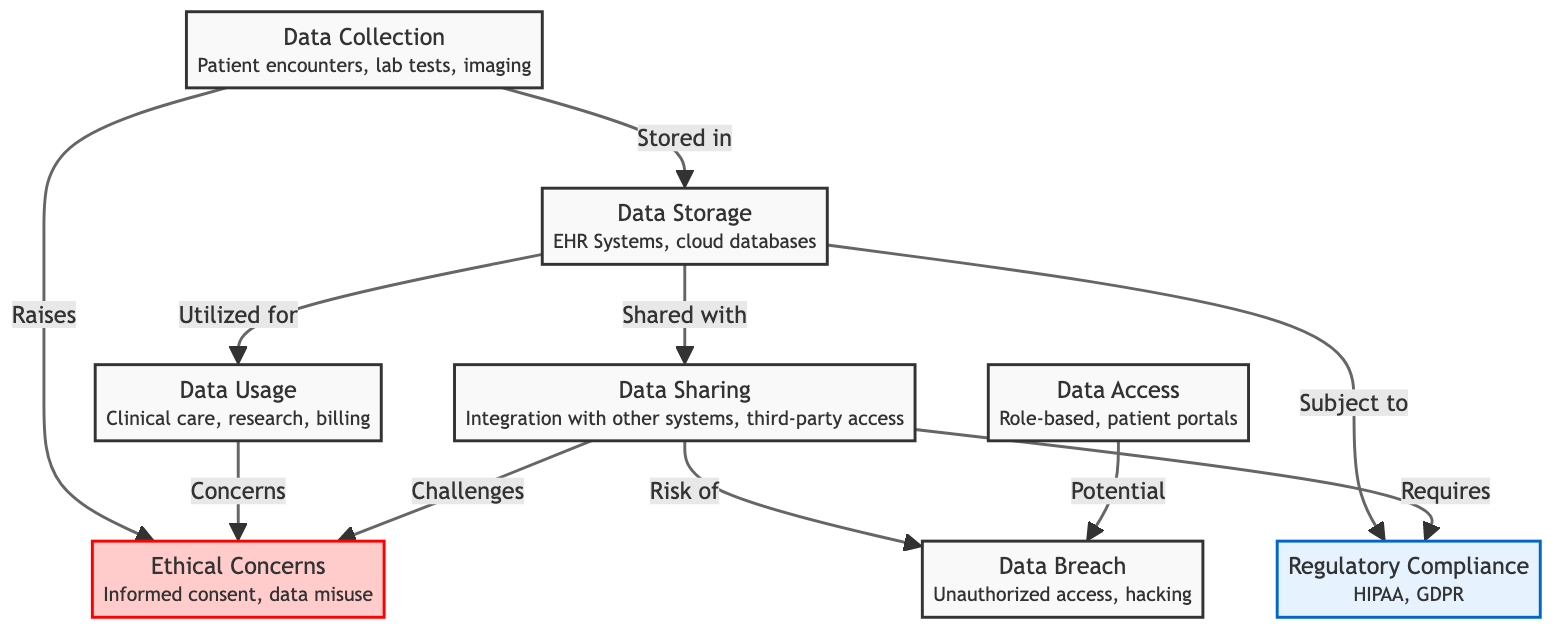What is the first step in the lifecycle of patient data? The diagram indicates that the lifecycle starts with "Data Collection" which involves patient encounters, lab tests, and imaging.
Answer: Data Collection How many main stages are there in the patient data lifecycle? By counting the labeled nodes in the diagram, we see there are six main stages described: Data Collection, Data Storage, Data Usage, Data Sharing, Data Access, and Data Breach.
Answer: Six Which node raises ethical concerns? The diagram shows that both "Data Collection" and "Data Usage" nodes lead to "Ethical Concerns," meaning they are responsible for raising issues regarding informed consent and data misuse.
Answer: Data Collection, Data Usage What type of compliance is required for data sharing? The diagram highlights that "Data Sharing" is an aspect that "Requires" regulatory compliance, specifically illustrating a connection with the "Regulatory Compliance" node, which mentions HIPAA and GDPR.
Answer: Regulatory Compliance What is a potential risk associated with data access? The arrows in the diagram indicate that "Data Access" has a potential risk leading to "Data Breach," demonstrating that unauthorized access and hacking are concerns in this context.
Answer: Data Breach What are two main regulatory compliance standards noted in the diagram? The "Regulatory Compliance" node specifically lists HIPAA and GDPR as the key standards relevant to the handling of patient data according to the diagram.
Answer: HIPAA, GDPR Which nodes flow into the "Ethical Concerns" node? The diagram illustrates that "Data Collection," "Data Usage," and "Data Sharing" all lead into the "Ethical Concerns" node, indicating multiple processes can raise ethical issues.
Answer: Data Collection, Data Usage, Data Sharing Which step involves integration with other systems? The "Data Sharing" node explicitly describes the integration with other systems and mentions third-party access as part of its role in the patient data lifecycle.
Answer: Data Sharing How does unauthorized access occur according to the diagram? The diagram indicates that unauthorized access can occur through both "Data Sharing" and "Data Access," which pose risks for a potential "Data Breach."
Answer: Data Sharing, Data Access 